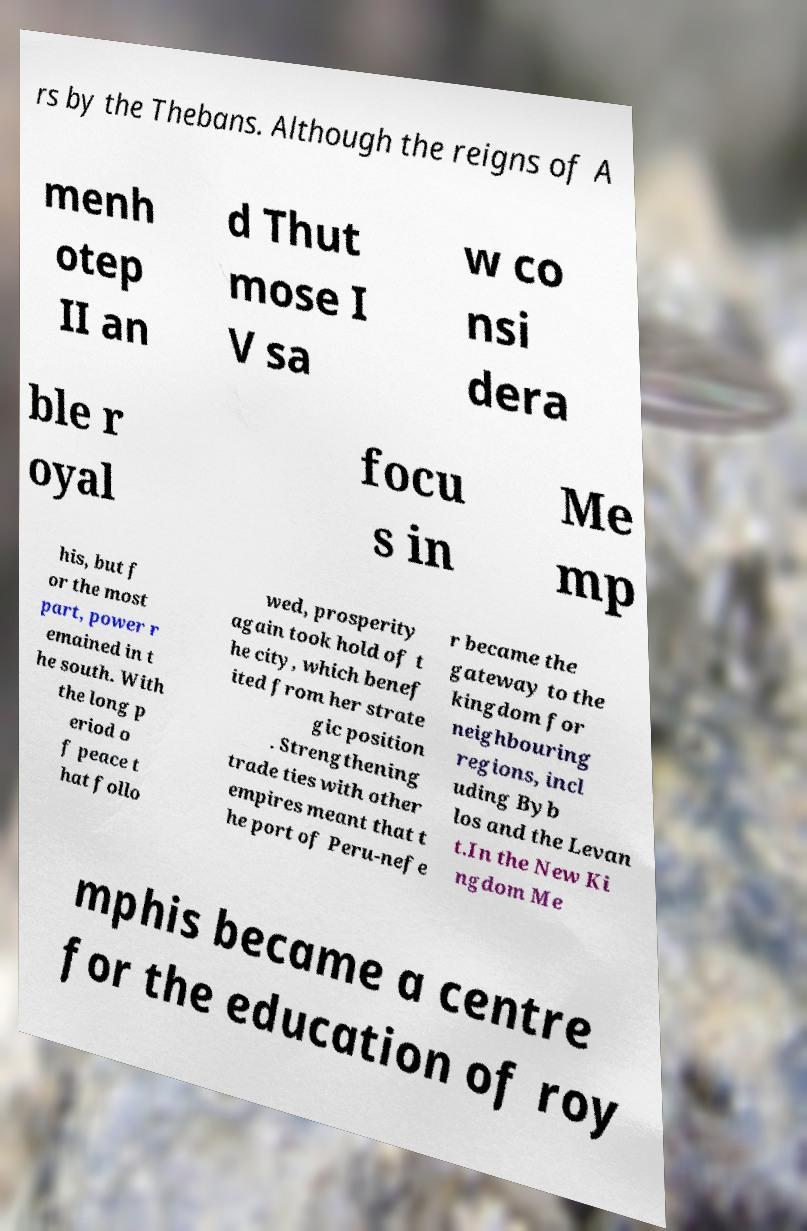For documentation purposes, I need the text within this image transcribed. Could you provide that? rs by the Thebans. Although the reigns of A menh otep II an d Thut mose I V sa w co nsi dera ble r oyal focu s in Me mp his, but f or the most part, power r emained in t he south. With the long p eriod o f peace t hat follo wed, prosperity again took hold of t he city, which benef ited from her strate gic position . Strengthening trade ties with other empires meant that t he port of Peru-nefe r became the gateway to the kingdom for neighbouring regions, incl uding Byb los and the Levan t.In the New Ki ngdom Me mphis became a centre for the education of roy 